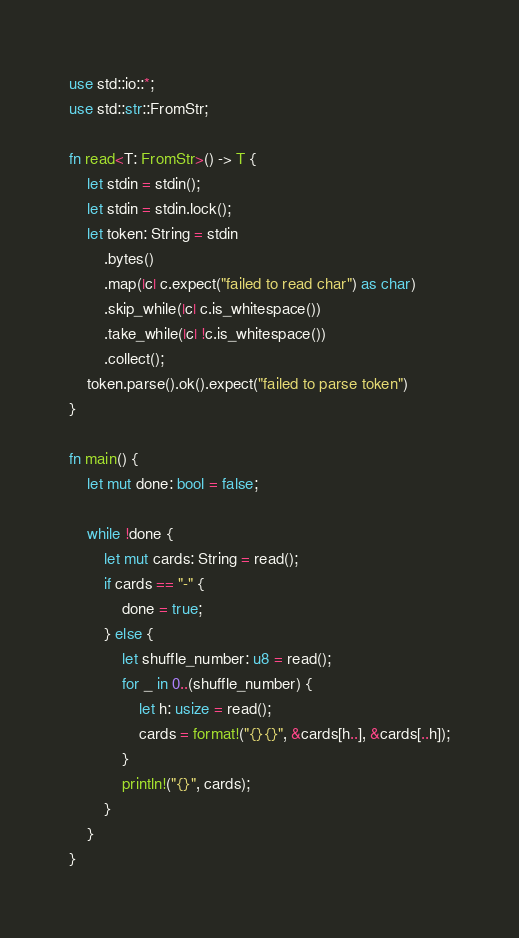<code> <loc_0><loc_0><loc_500><loc_500><_Rust_>use std::io::*;
use std::str::FromStr;

fn read<T: FromStr>() -> T {
    let stdin = stdin();
    let stdin = stdin.lock();
    let token: String = stdin
        .bytes()
        .map(|c| c.expect("failed to read char") as char)
        .skip_while(|c| c.is_whitespace())
        .take_while(|c| !c.is_whitespace())
        .collect();
    token.parse().ok().expect("failed to parse token")
}

fn main() {
    let mut done: bool = false;

    while !done {
        let mut cards: String = read();
        if cards == "-" {
            done = true;
        } else {
            let shuffle_number: u8 = read();
            for _ in 0..(shuffle_number) {
                let h: usize = read();
                cards = format!("{}{}", &cards[h..], &cards[..h]);
            }
            println!("{}", cards);
        }
    }
}

</code> 